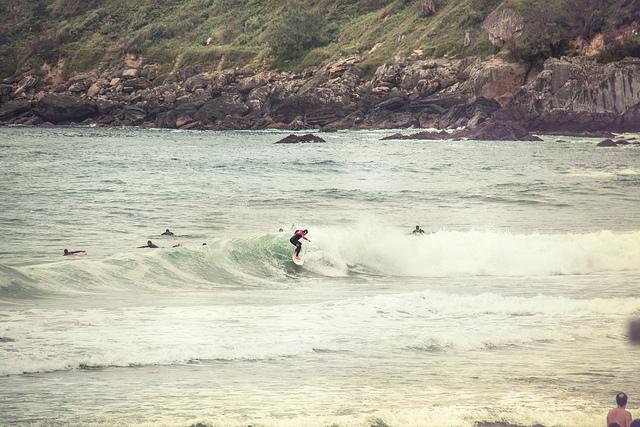What other activity can be carried out here besides surfing? swimming 